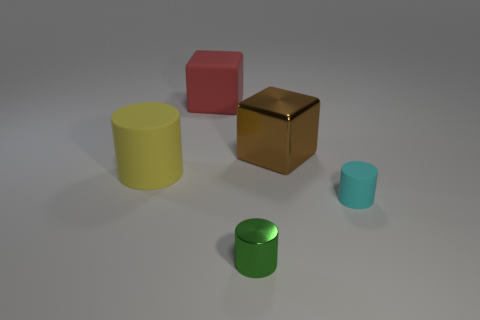There is a red object that is the same material as the yellow cylinder; what is its size?
Your response must be concise. Large. Is the size of the brown shiny thing the same as the matte cylinder that is on the right side of the green metal object?
Give a very brief answer. No. What shape is the matte object behind the brown block?
Offer a very short reply. Cube. There is a small cyan object in front of the cylinder that is behind the cyan object; are there any big cylinders in front of it?
Ensure brevity in your answer.  No. There is a tiny green thing that is the same shape as the tiny cyan matte object; what is its material?
Your response must be concise. Metal. Is there any other thing that is made of the same material as the large red object?
Your answer should be very brief. Yes. How many blocks are brown objects or tiny objects?
Your answer should be very brief. 1. There is a matte cylinder that is to the right of the red rubber thing; does it have the same size as the matte cylinder to the left of the small cyan thing?
Provide a short and direct response. No. What material is the block in front of the block that is left of the big brown metal cube?
Give a very brief answer. Metal. Is the number of large rubber cylinders that are to the right of the green object less than the number of small blocks?
Provide a succinct answer. No. 